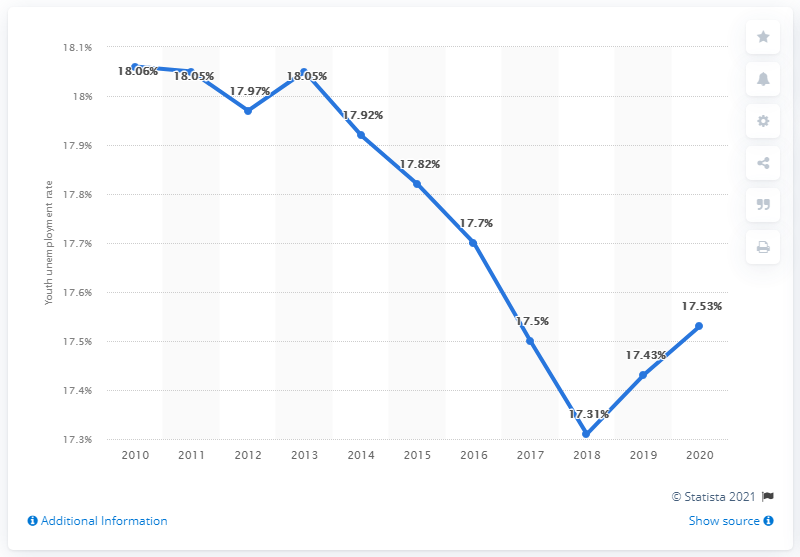Highlight a few significant elements in this photo. As of 2013, the unemployment rate was 18.05%. The average of 2018, 2019, and 2020 is 17.42. 